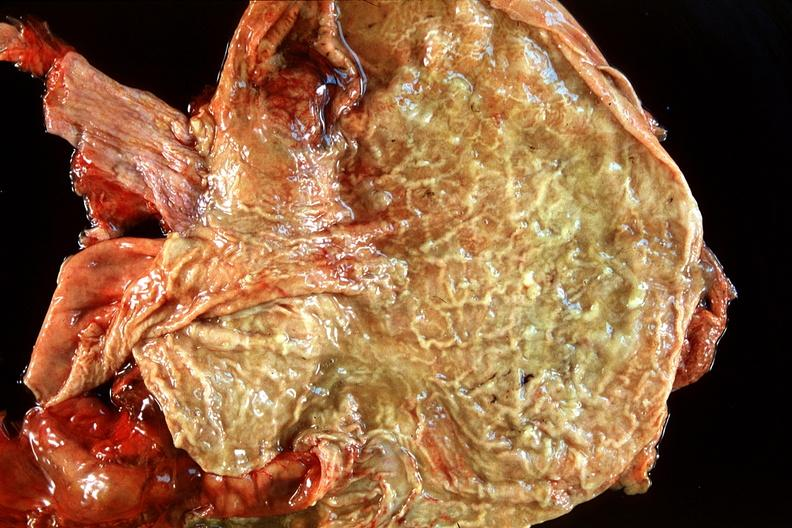s gastrointestinal present?
Answer the question using a single word or phrase. Yes 